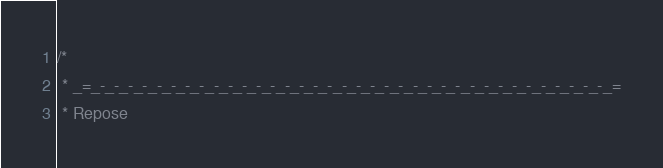<code> <loc_0><loc_0><loc_500><loc_500><_Scala_>/*
 * _=_-_-_-_-_-_-_-_-_-_-_-_-_-_-_-_-_-_-_-_-_-_-_-_-_-_-_-_-_-_-_-_-_-_-_-_-_=
 * Repose</code> 